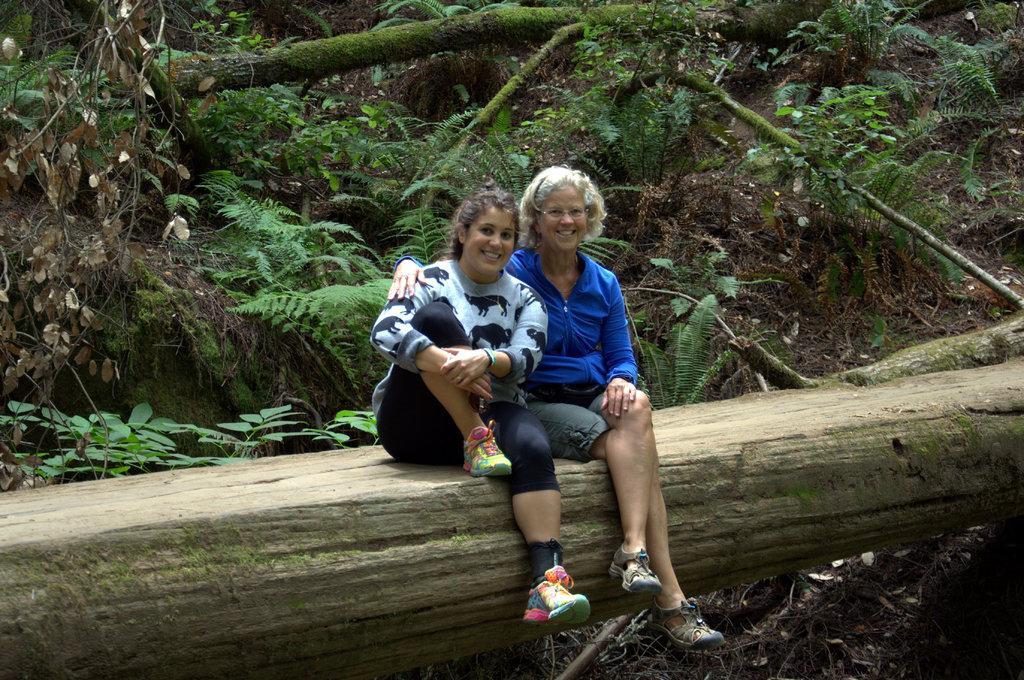Describe this image in one or two sentences. In this image there are two persons smiling and sitting on the trunk, and in the background there are plants. 